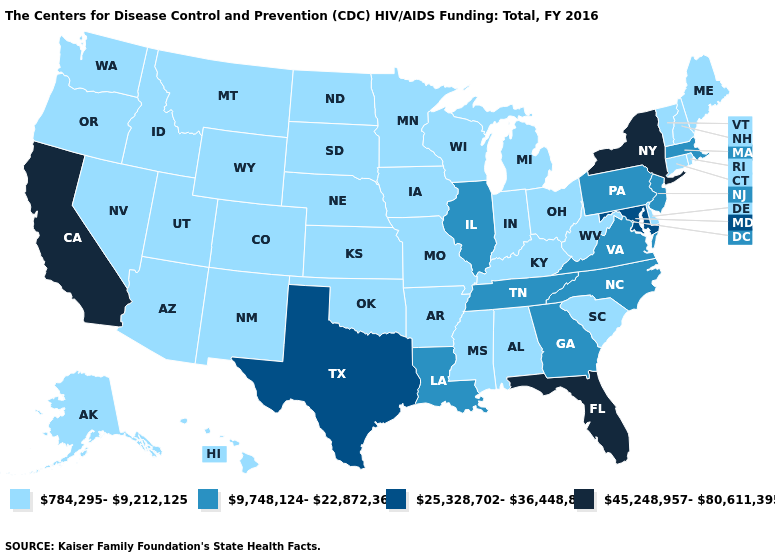Which states have the lowest value in the Northeast?
Be succinct. Connecticut, Maine, New Hampshire, Rhode Island, Vermont. What is the lowest value in states that border Massachusetts?
Give a very brief answer. 784,295-9,212,125. What is the value of California?
Give a very brief answer. 45,248,957-80,611,395. Among the states that border North Dakota , which have the lowest value?
Concise answer only. Minnesota, Montana, South Dakota. How many symbols are there in the legend?
Be succinct. 4. Does Washington have the same value as Florida?
Keep it brief. No. What is the value of Arkansas?
Be succinct. 784,295-9,212,125. What is the highest value in the MidWest ?
Keep it brief. 9,748,124-22,872,366. Among the states that border Wisconsin , does Michigan have the lowest value?
Answer briefly. Yes. Is the legend a continuous bar?
Be succinct. No. What is the value of Tennessee?
Give a very brief answer. 9,748,124-22,872,366. Name the states that have a value in the range 25,328,702-36,448,881?
Keep it brief. Maryland, Texas. Name the states that have a value in the range 784,295-9,212,125?
Be succinct. Alabama, Alaska, Arizona, Arkansas, Colorado, Connecticut, Delaware, Hawaii, Idaho, Indiana, Iowa, Kansas, Kentucky, Maine, Michigan, Minnesota, Mississippi, Missouri, Montana, Nebraska, Nevada, New Hampshire, New Mexico, North Dakota, Ohio, Oklahoma, Oregon, Rhode Island, South Carolina, South Dakota, Utah, Vermont, Washington, West Virginia, Wisconsin, Wyoming. Is the legend a continuous bar?
Short answer required. No. What is the value of South Dakota?
Short answer required. 784,295-9,212,125. 